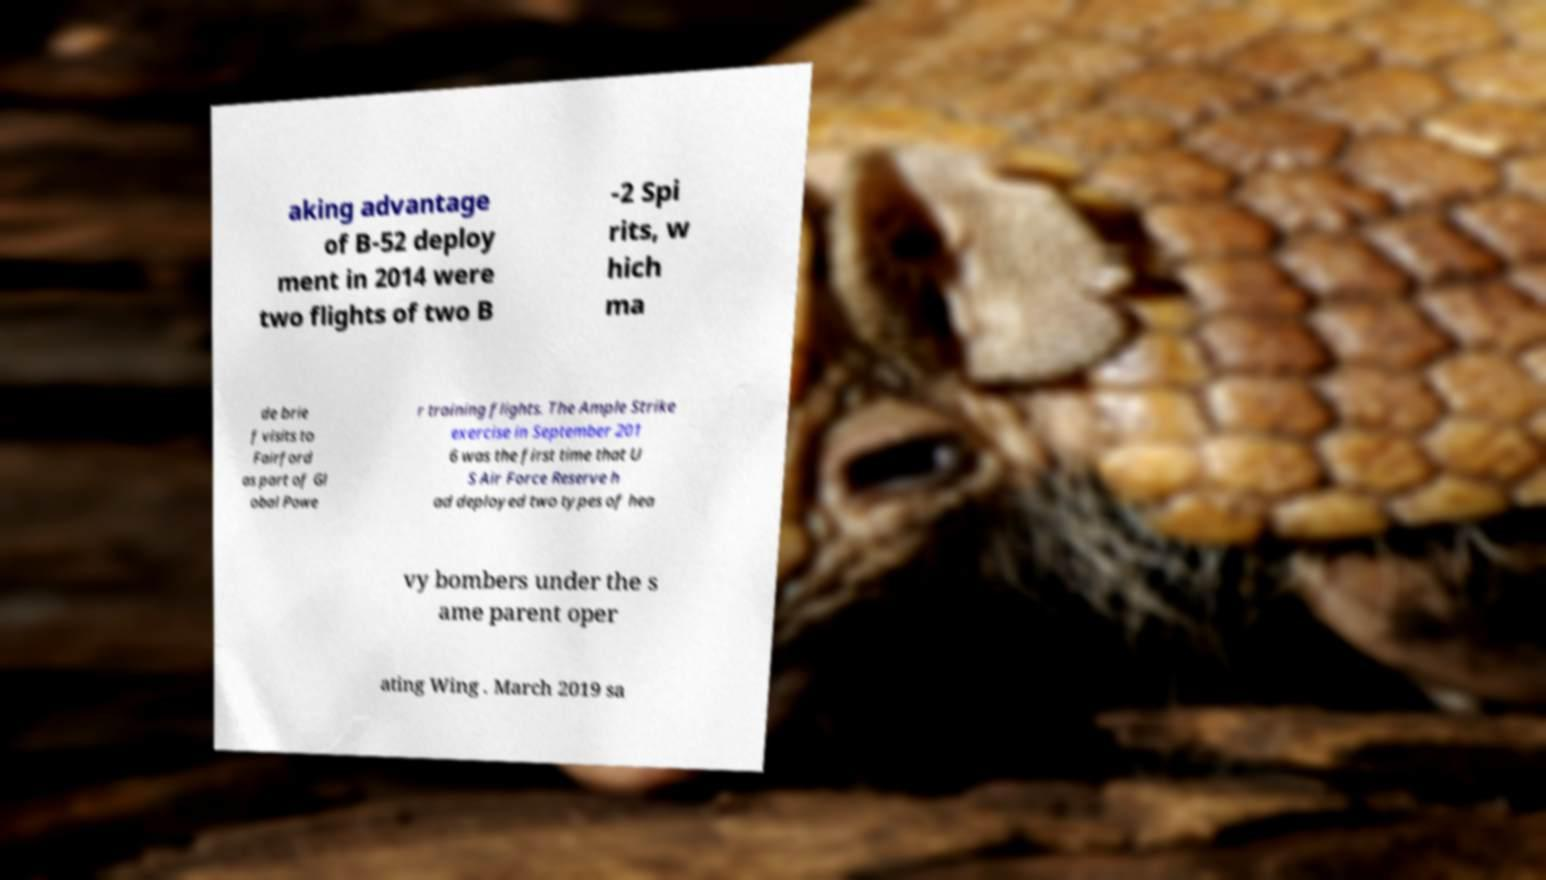There's text embedded in this image that I need extracted. Can you transcribe it verbatim? aking advantage of B-52 deploy ment in 2014 were two flights of two B -2 Spi rits, w hich ma de brie f visits to Fairford as part of Gl obal Powe r training flights. The Ample Strike exercise in September 201 6 was the first time that U S Air Force Reserve h ad deployed two types of hea vy bombers under the s ame parent oper ating Wing . March 2019 sa 